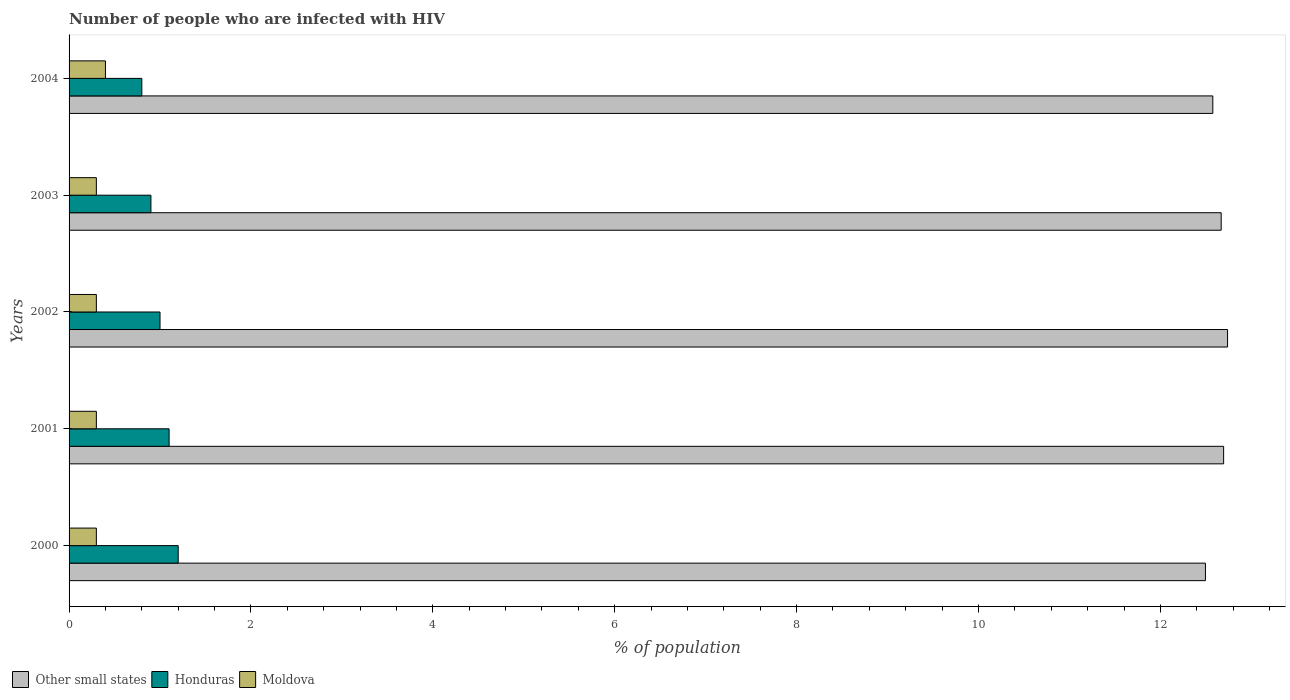Are the number of bars per tick equal to the number of legend labels?
Give a very brief answer. Yes. How many bars are there on the 1st tick from the top?
Make the answer very short. 3. How many bars are there on the 4th tick from the bottom?
Your response must be concise. 3. What is the label of the 5th group of bars from the top?
Ensure brevity in your answer.  2000. What is the percentage of HIV infected population in in Honduras in 2000?
Ensure brevity in your answer.  1.2. Across all years, what is the minimum percentage of HIV infected population in in Honduras?
Give a very brief answer. 0.8. In which year was the percentage of HIV infected population in in Other small states maximum?
Offer a terse response. 2002. In which year was the percentage of HIV infected population in in Moldova minimum?
Offer a very short reply. 2000. What is the difference between the percentage of HIV infected population in in Other small states in 2000 and that in 2004?
Ensure brevity in your answer.  -0.08. What is the difference between the percentage of HIV infected population in in Moldova in 2000 and the percentage of HIV infected population in in Other small states in 2002?
Offer a very short reply. -12.44. What is the average percentage of HIV infected population in in Moldova per year?
Your answer should be compact. 0.32. In the year 2000, what is the difference between the percentage of HIV infected population in in Moldova and percentage of HIV infected population in in Other small states?
Keep it short and to the point. -12.2. What is the ratio of the percentage of HIV infected population in in Moldova in 2000 to that in 2003?
Provide a succinct answer. 1. Is the percentage of HIV infected population in in Honduras in 2000 less than that in 2003?
Provide a succinct answer. No. Is the difference between the percentage of HIV infected population in in Moldova in 2000 and 2004 greater than the difference between the percentage of HIV infected population in in Other small states in 2000 and 2004?
Provide a succinct answer. No. What is the difference between the highest and the second highest percentage of HIV infected population in in Honduras?
Provide a succinct answer. 0.1. What is the difference between the highest and the lowest percentage of HIV infected population in in Other small states?
Offer a very short reply. 0.24. In how many years, is the percentage of HIV infected population in in Honduras greater than the average percentage of HIV infected population in in Honduras taken over all years?
Offer a terse response. 2. Is the sum of the percentage of HIV infected population in in Honduras in 2002 and 2003 greater than the maximum percentage of HIV infected population in in Moldova across all years?
Your answer should be very brief. Yes. What does the 1st bar from the top in 2001 represents?
Your answer should be compact. Moldova. What does the 2nd bar from the bottom in 2000 represents?
Keep it short and to the point. Honduras. Are all the bars in the graph horizontal?
Give a very brief answer. Yes. How many years are there in the graph?
Ensure brevity in your answer.  5. What is the difference between two consecutive major ticks on the X-axis?
Offer a terse response. 2. Are the values on the major ticks of X-axis written in scientific E-notation?
Provide a succinct answer. No. Does the graph contain any zero values?
Offer a very short reply. No. How many legend labels are there?
Your answer should be very brief. 3. How are the legend labels stacked?
Keep it short and to the point. Horizontal. What is the title of the graph?
Make the answer very short. Number of people who are infected with HIV. Does "Sao Tome and Principe" appear as one of the legend labels in the graph?
Offer a very short reply. No. What is the label or title of the X-axis?
Provide a succinct answer. % of population. What is the % of population in Other small states in 2000?
Ensure brevity in your answer.  12.5. What is the % of population of Honduras in 2000?
Make the answer very short. 1.2. What is the % of population of Moldova in 2000?
Give a very brief answer. 0.3. What is the % of population of Other small states in 2001?
Provide a succinct answer. 12.7. What is the % of population in Other small states in 2002?
Your response must be concise. 12.74. What is the % of population of Other small states in 2003?
Provide a short and direct response. 12.67. What is the % of population in Moldova in 2003?
Provide a short and direct response. 0.3. What is the % of population in Other small states in 2004?
Offer a terse response. 12.58. Across all years, what is the maximum % of population in Other small states?
Provide a succinct answer. 12.74. Across all years, what is the minimum % of population in Other small states?
Make the answer very short. 12.5. Across all years, what is the minimum % of population of Honduras?
Provide a succinct answer. 0.8. Across all years, what is the minimum % of population of Moldova?
Ensure brevity in your answer.  0.3. What is the total % of population of Other small states in the graph?
Provide a succinct answer. 63.18. What is the total % of population in Honduras in the graph?
Offer a terse response. 5. What is the total % of population of Moldova in the graph?
Provide a succinct answer. 1.6. What is the difference between the % of population in Moldova in 2000 and that in 2001?
Give a very brief answer. 0. What is the difference between the % of population in Other small states in 2000 and that in 2002?
Keep it short and to the point. -0.24. What is the difference between the % of population of Honduras in 2000 and that in 2002?
Provide a short and direct response. 0.2. What is the difference between the % of population of Moldova in 2000 and that in 2002?
Make the answer very short. 0. What is the difference between the % of population of Other small states in 2000 and that in 2003?
Make the answer very short. -0.17. What is the difference between the % of population of Moldova in 2000 and that in 2003?
Your answer should be compact. 0. What is the difference between the % of population in Other small states in 2000 and that in 2004?
Your response must be concise. -0.08. What is the difference between the % of population in Other small states in 2001 and that in 2002?
Provide a short and direct response. -0.04. What is the difference between the % of population of Honduras in 2001 and that in 2002?
Your answer should be compact. 0.1. What is the difference between the % of population of Moldova in 2001 and that in 2002?
Offer a terse response. 0. What is the difference between the % of population of Other small states in 2001 and that in 2003?
Your answer should be compact. 0.03. What is the difference between the % of population in Other small states in 2001 and that in 2004?
Provide a short and direct response. 0.12. What is the difference between the % of population of Moldova in 2001 and that in 2004?
Offer a terse response. -0.1. What is the difference between the % of population in Other small states in 2002 and that in 2003?
Your answer should be compact. 0.07. What is the difference between the % of population of Other small states in 2002 and that in 2004?
Give a very brief answer. 0.16. What is the difference between the % of population of Moldova in 2002 and that in 2004?
Your answer should be compact. -0.1. What is the difference between the % of population of Other small states in 2003 and that in 2004?
Your answer should be very brief. 0.09. What is the difference between the % of population of Other small states in 2000 and the % of population of Honduras in 2001?
Offer a terse response. 11.4. What is the difference between the % of population of Other small states in 2000 and the % of population of Moldova in 2001?
Ensure brevity in your answer.  12.2. What is the difference between the % of population of Honduras in 2000 and the % of population of Moldova in 2001?
Provide a short and direct response. 0.9. What is the difference between the % of population of Other small states in 2000 and the % of population of Honduras in 2002?
Ensure brevity in your answer.  11.5. What is the difference between the % of population in Other small states in 2000 and the % of population in Moldova in 2002?
Offer a very short reply. 12.2. What is the difference between the % of population in Other small states in 2000 and the % of population in Honduras in 2003?
Offer a terse response. 11.6. What is the difference between the % of population in Other small states in 2000 and the % of population in Moldova in 2003?
Provide a succinct answer. 12.2. What is the difference between the % of population in Honduras in 2000 and the % of population in Moldova in 2003?
Give a very brief answer. 0.9. What is the difference between the % of population of Other small states in 2000 and the % of population of Honduras in 2004?
Provide a short and direct response. 11.7. What is the difference between the % of population of Other small states in 2000 and the % of population of Moldova in 2004?
Offer a terse response. 12.1. What is the difference between the % of population of Other small states in 2001 and the % of population of Honduras in 2002?
Your response must be concise. 11.7. What is the difference between the % of population in Other small states in 2001 and the % of population in Moldova in 2002?
Provide a succinct answer. 12.4. What is the difference between the % of population in Honduras in 2001 and the % of population in Moldova in 2002?
Make the answer very short. 0.8. What is the difference between the % of population of Other small states in 2001 and the % of population of Honduras in 2003?
Give a very brief answer. 11.8. What is the difference between the % of population of Other small states in 2001 and the % of population of Moldova in 2003?
Ensure brevity in your answer.  12.4. What is the difference between the % of population in Other small states in 2001 and the % of population in Honduras in 2004?
Your answer should be very brief. 11.9. What is the difference between the % of population in Other small states in 2001 and the % of population in Moldova in 2004?
Your answer should be very brief. 12.3. What is the difference between the % of population of Honduras in 2001 and the % of population of Moldova in 2004?
Give a very brief answer. 0.7. What is the difference between the % of population in Other small states in 2002 and the % of population in Honduras in 2003?
Your response must be concise. 11.84. What is the difference between the % of population in Other small states in 2002 and the % of population in Moldova in 2003?
Offer a very short reply. 12.44. What is the difference between the % of population of Honduras in 2002 and the % of population of Moldova in 2003?
Your answer should be compact. 0.7. What is the difference between the % of population in Other small states in 2002 and the % of population in Honduras in 2004?
Ensure brevity in your answer.  11.94. What is the difference between the % of population in Other small states in 2002 and the % of population in Moldova in 2004?
Ensure brevity in your answer.  12.34. What is the difference between the % of population of Other small states in 2003 and the % of population of Honduras in 2004?
Your answer should be very brief. 11.87. What is the difference between the % of population of Other small states in 2003 and the % of population of Moldova in 2004?
Your answer should be compact. 12.27. What is the difference between the % of population in Honduras in 2003 and the % of population in Moldova in 2004?
Make the answer very short. 0.5. What is the average % of population in Other small states per year?
Provide a succinct answer. 12.63. What is the average % of population in Honduras per year?
Make the answer very short. 1. What is the average % of population of Moldova per year?
Your answer should be compact. 0.32. In the year 2000, what is the difference between the % of population in Other small states and % of population in Honduras?
Make the answer very short. 11.3. In the year 2000, what is the difference between the % of population of Other small states and % of population of Moldova?
Offer a terse response. 12.2. In the year 2000, what is the difference between the % of population of Honduras and % of population of Moldova?
Offer a very short reply. 0.9. In the year 2001, what is the difference between the % of population in Other small states and % of population in Honduras?
Give a very brief answer. 11.6. In the year 2001, what is the difference between the % of population of Other small states and % of population of Moldova?
Offer a very short reply. 12.4. In the year 2001, what is the difference between the % of population in Honduras and % of population in Moldova?
Offer a terse response. 0.8. In the year 2002, what is the difference between the % of population of Other small states and % of population of Honduras?
Keep it short and to the point. 11.74. In the year 2002, what is the difference between the % of population of Other small states and % of population of Moldova?
Offer a very short reply. 12.44. In the year 2003, what is the difference between the % of population in Other small states and % of population in Honduras?
Offer a very short reply. 11.77. In the year 2003, what is the difference between the % of population of Other small states and % of population of Moldova?
Make the answer very short. 12.37. In the year 2003, what is the difference between the % of population in Honduras and % of population in Moldova?
Give a very brief answer. 0.6. In the year 2004, what is the difference between the % of population of Other small states and % of population of Honduras?
Keep it short and to the point. 11.78. In the year 2004, what is the difference between the % of population of Other small states and % of population of Moldova?
Offer a terse response. 12.18. In the year 2004, what is the difference between the % of population in Honduras and % of population in Moldova?
Your answer should be very brief. 0.4. What is the ratio of the % of population of Other small states in 2000 to that in 2001?
Offer a very short reply. 0.98. What is the ratio of the % of population in Moldova in 2000 to that in 2001?
Offer a very short reply. 1. What is the ratio of the % of population of Other small states in 2000 to that in 2002?
Offer a very short reply. 0.98. What is the ratio of the % of population of Honduras in 2000 to that in 2002?
Provide a succinct answer. 1.2. What is the ratio of the % of population of Moldova in 2000 to that in 2002?
Give a very brief answer. 1. What is the ratio of the % of population of Other small states in 2000 to that in 2003?
Provide a short and direct response. 0.99. What is the ratio of the % of population in Honduras in 2000 to that in 2003?
Give a very brief answer. 1.33. What is the ratio of the % of population of Other small states in 2000 to that in 2004?
Give a very brief answer. 0.99. What is the ratio of the % of population in Honduras in 2000 to that in 2004?
Your response must be concise. 1.5. What is the ratio of the % of population in Moldova in 2001 to that in 2002?
Offer a very short reply. 1. What is the ratio of the % of population of Other small states in 2001 to that in 2003?
Your answer should be compact. 1. What is the ratio of the % of population in Honduras in 2001 to that in 2003?
Keep it short and to the point. 1.22. What is the ratio of the % of population of Moldova in 2001 to that in 2003?
Make the answer very short. 1. What is the ratio of the % of population of Other small states in 2001 to that in 2004?
Give a very brief answer. 1.01. What is the ratio of the % of population in Honduras in 2001 to that in 2004?
Provide a short and direct response. 1.38. What is the ratio of the % of population in Moldova in 2001 to that in 2004?
Give a very brief answer. 0.75. What is the ratio of the % of population in Other small states in 2002 to that in 2003?
Provide a short and direct response. 1.01. What is the ratio of the % of population of Honduras in 2002 to that in 2003?
Ensure brevity in your answer.  1.11. What is the ratio of the % of population of Other small states in 2002 to that in 2004?
Provide a short and direct response. 1.01. What is the ratio of the % of population in Honduras in 2002 to that in 2004?
Ensure brevity in your answer.  1.25. What is the ratio of the % of population of Other small states in 2003 to that in 2004?
Give a very brief answer. 1.01. What is the ratio of the % of population of Honduras in 2003 to that in 2004?
Provide a short and direct response. 1.12. What is the ratio of the % of population in Moldova in 2003 to that in 2004?
Your answer should be very brief. 0.75. What is the difference between the highest and the second highest % of population in Other small states?
Provide a short and direct response. 0.04. What is the difference between the highest and the second highest % of population in Honduras?
Your answer should be compact. 0.1. What is the difference between the highest and the second highest % of population in Moldova?
Ensure brevity in your answer.  0.1. What is the difference between the highest and the lowest % of population in Other small states?
Your answer should be compact. 0.24. What is the difference between the highest and the lowest % of population of Moldova?
Keep it short and to the point. 0.1. 